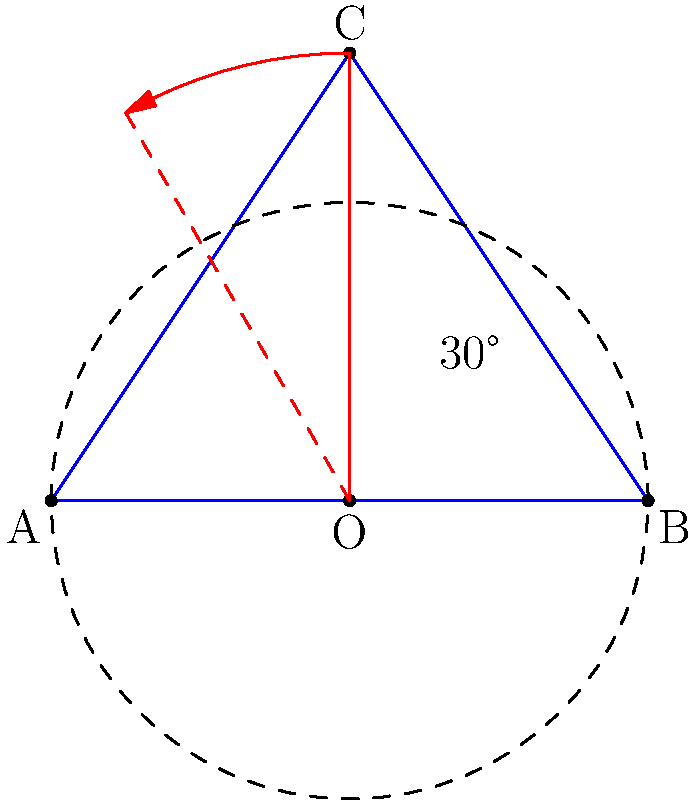In the Late Night with Seth Meyers intro animation, the show's triangular logo rotates around a fixed point. If the triangle ABC represents the logo with vertices A(0,0), B(4,0), and C(2,3), and it rotates 30° counterclockwise around point O(2,0), what are the coordinates of point C after rotation? Round your answer to two decimal places. To find the coordinates of point C after rotation, we can follow these steps:

1) First, we need to use the rotation matrix for a counterclockwise rotation by angle $\theta$:

   $R(\theta) = \begin{bmatrix} \cos\theta & -\sin\theta \\ \sin\theta & \cos\theta \end{bmatrix}$

2) For a 30° rotation, $\theta = 30° = \frac{\pi}{6}$ radians. So our rotation matrix is:

   $R(30°) = \begin{bmatrix} \cos\frac{\pi}{6} & -\sin\frac{\pi}{6} \\ \sin\frac{\pi}{6} & \cos\frac{\pi}{6} \end{bmatrix} = \begin{bmatrix} \frac{\sqrt{3}}{2} & -\frac{1}{2} \\ \frac{1}{2} & \frac{\sqrt{3}}{2} \end{bmatrix}$

3) To rotate around point O(2,0), we first translate the triangle so that O is at the origin, then rotate, then translate back:

   $C_{rotated} = R(30°)(C - O) + O$

4) $C - O = (2,3) - (2,0) = (0,3)$

5) Applying the rotation:

   $R(30°)(0,3) = \begin{bmatrix} \frac{\sqrt{3}}{2} & -\frac{1}{2} \\ \frac{1}{2} & \frac{\sqrt{3}}{2} \end{bmatrix} \begin{pmatrix} 0 \\ 3 \end{pmatrix} = \begin{pmatrix} -\frac{3}{2} \\ \frac{3\sqrt{3}}{2} \end{pmatrix}$

6) Translating back:

   $C_{rotated} = (-\frac{3}{2}, \frac{3\sqrt{3}}{2}) + (2,0) = (\frac{1}{2}, \frac{3\sqrt{3}}{2})$

7) Converting to decimal form and rounding to two decimal places:

   $C_{rotated} \approx (0.50, 2.60)$
Answer: (0.50, 2.60) 